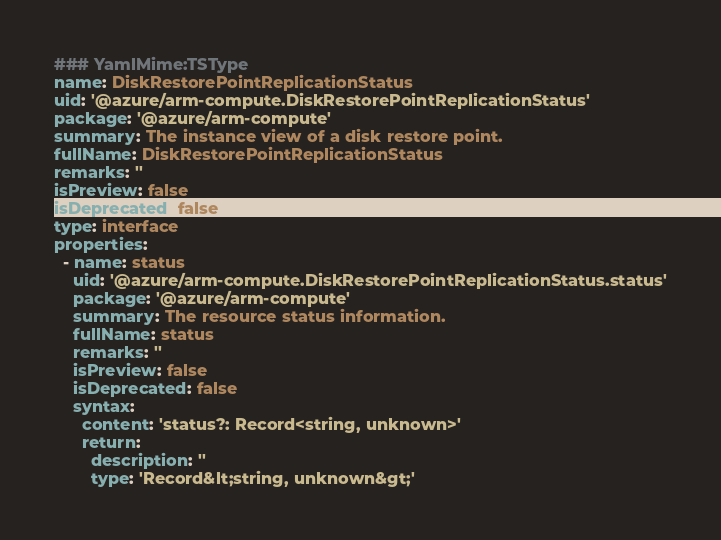Convert code to text. <code><loc_0><loc_0><loc_500><loc_500><_YAML_>### YamlMime:TSType
name: DiskRestorePointReplicationStatus
uid: '@azure/arm-compute.DiskRestorePointReplicationStatus'
package: '@azure/arm-compute'
summary: The instance view of a disk restore point.
fullName: DiskRestorePointReplicationStatus
remarks: ''
isPreview: false
isDeprecated: false
type: interface
properties:
  - name: status
    uid: '@azure/arm-compute.DiskRestorePointReplicationStatus.status'
    package: '@azure/arm-compute'
    summary: The resource status information.
    fullName: status
    remarks: ''
    isPreview: false
    isDeprecated: false
    syntax:
      content: 'status?: Record<string, unknown>'
      return:
        description: ''
        type: 'Record&lt;string, unknown&gt;'
</code> 